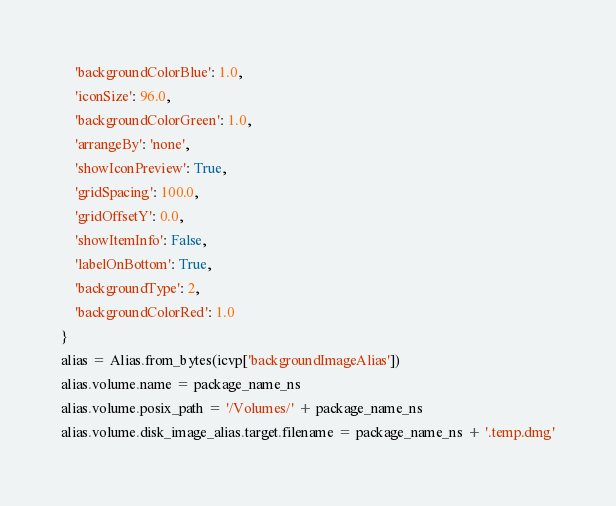<code> <loc_0><loc_0><loc_500><loc_500><_Python_>    'backgroundColorBlue': 1.0,
    'iconSize': 96.0,
    'backgroundColorGreen': 1.0,
    'arrangeBy': 'none',
    'showIconPreview': True,
    'gridSpacing': 100.0,
    'gridOffsetY': 0.0,
    'showItemInfo': False,
    'labelOnBottom': True,
    'backgroundType': 2,
    'backgroundColorRed': 1.0
}
alias = Alias.from_bytes(icvp['backgroundImageAlias'])
alias.volume.name = package_name_ns
alias.volume.posix_path = '/Volumes/' + package_name_ns
alias.volume.disk_image_alias.target.filename = package_name_ns + '.temp.dmg'</code> 